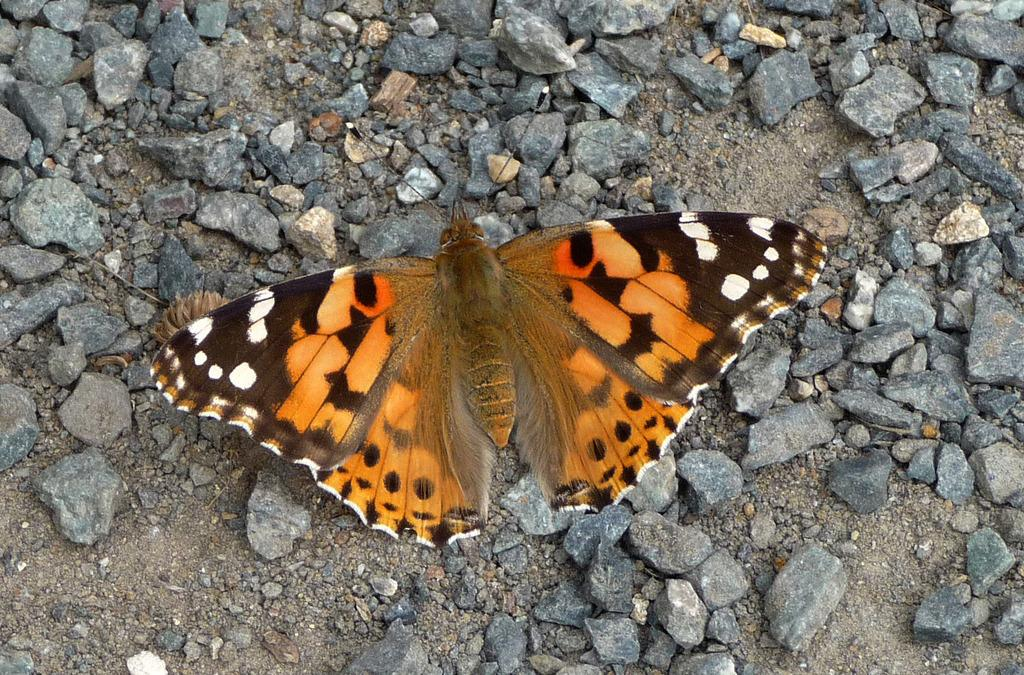What type of animal can be seen in the image? There is a butterfly in the image. Can you describe the colors of the butterfly? The butterfly has brown, orange, white, and black colors. What else can be seen in the image besides the butterfly? There are many stones visible in the image. What type of reward is the butterfly receiving for winning the competition in the image? There is no reward or competition present in the image; it only features a butterfly and stones. 